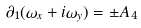<formula> <loc_0><loc_0><loc_500><loc_500>\partial _ { 1 } ( \omega _ { x } + i \omega _ { y } ) = \pm A _ { 4 }</formula> 